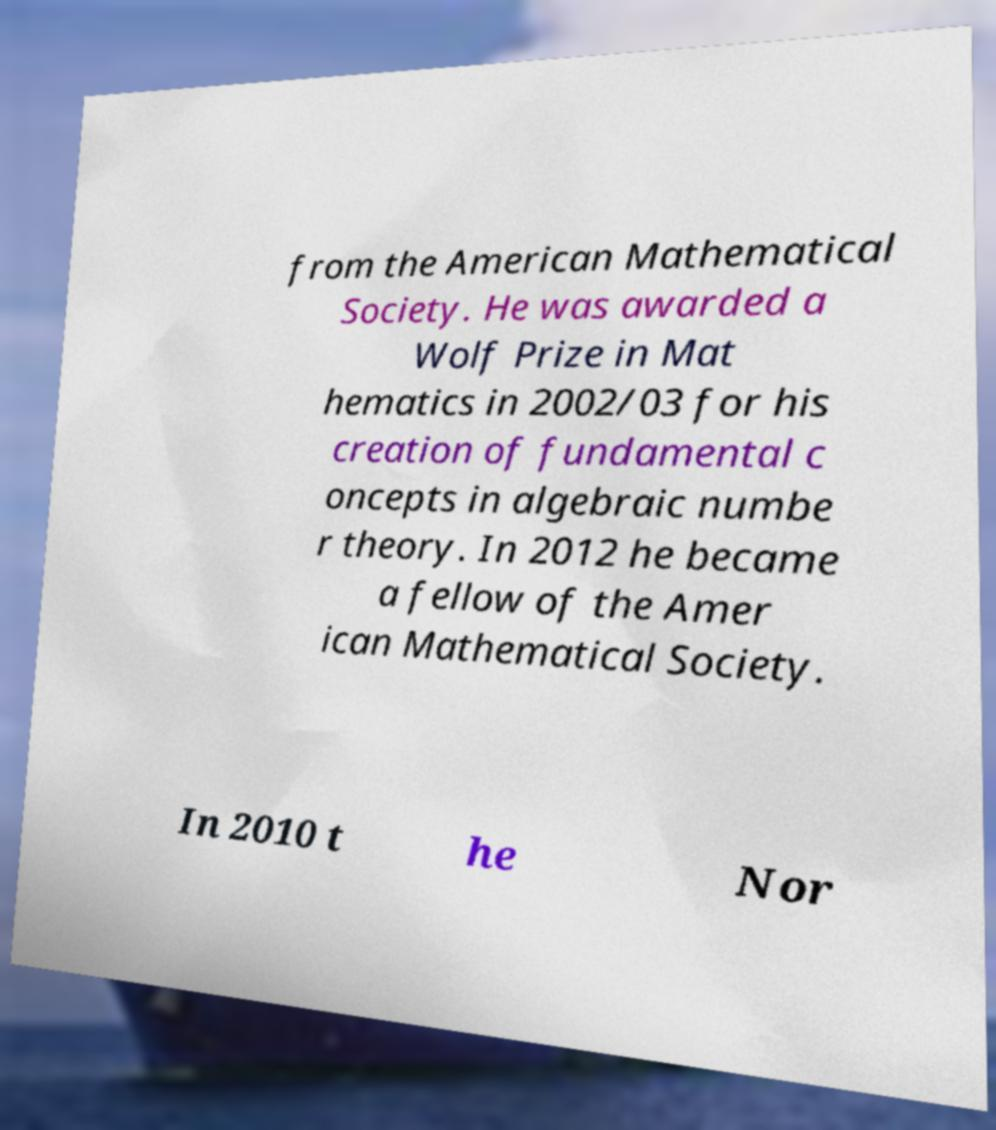For documentation purposes, I need the text within this image transcribed. Could you provide that? from the American Mathematical Society. He was awarded a Wolf Prize in Mat hematics in 2002/03 for his creation of fundamental c oncepts in algebraic numbe r theory. In 2012 he became a fellow of the Amer ican Mathematical Society. In 2010 t he Nor 